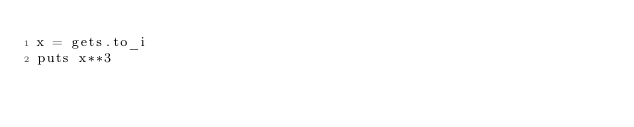<code> <loc_0><loc_0><loc_500><loc_500><_Ruby_>x = gets.to_i
puts x**3</code> 